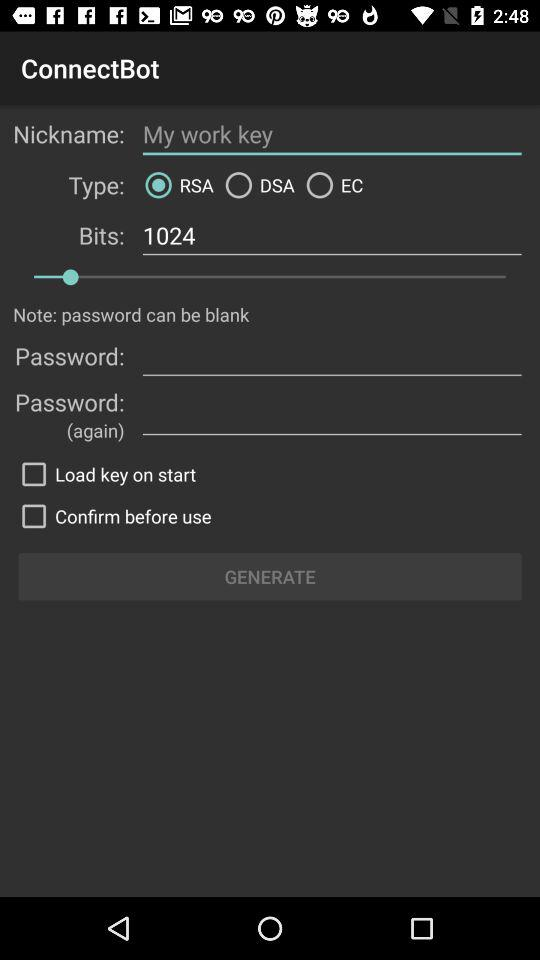What is the name of the application? The application name is "ConnectBot". 